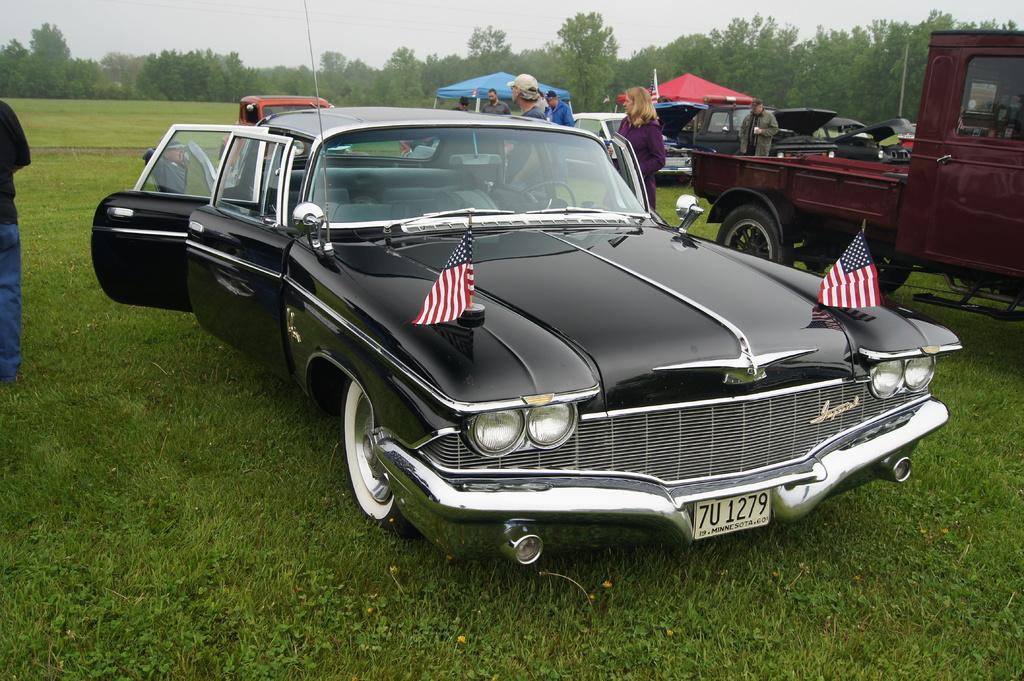Please provide a concise description of this image. In this image there are vehicles and we can see people. At the bottom there is grass. In the background there are trees and sky. We can see tents. 